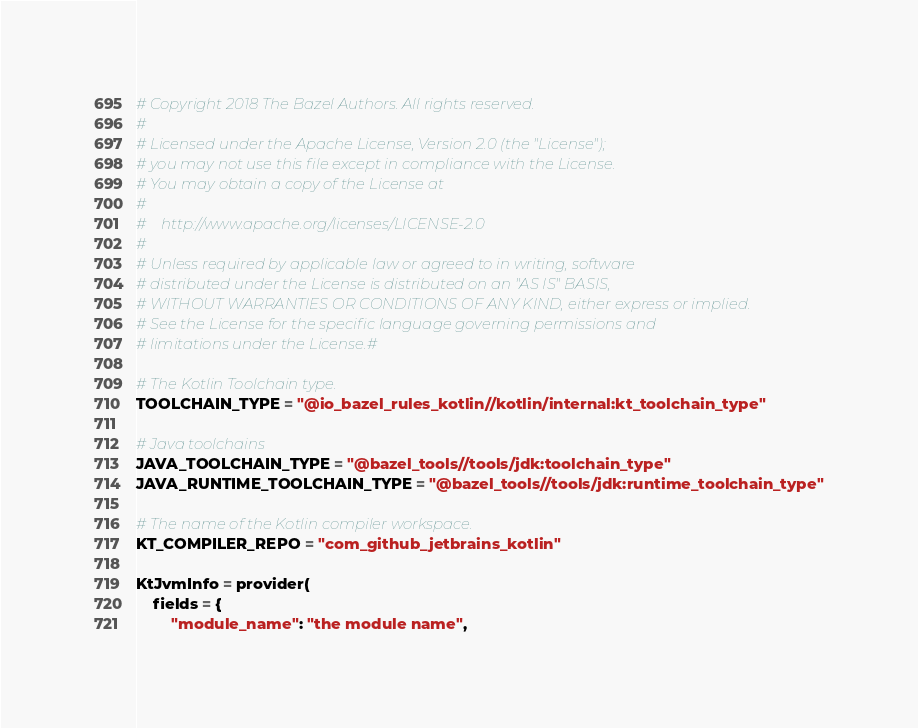<code> <loc_0><loc_0><loc_500><loc_500><_Python_># Copyright 2018 The Bazel Authors. All rights reserved.
#
# Licensed under the Apache License, Version 2.0 (the "License");
# you may not use this file except in compliance with the License.
# You may obtain a copy of the License at
#
#    http://www.apache.org/licenses/LICENSE-2.0
#
# Unless required by applicable law or agreed to in writing, software
# distributed under the License is distributed on an "AS IS" BASIS,
# WITHOUT WARRANTIES OR CONDITIONS OF ANY KIND, either express or implied.
# See the License for the specific language governing permissions and
# limitations under the License.#

# The Kotlin Toolchain type.
TOOLCHAIN_TYPE = "@io_bazel_rules_kotlin//kotlin/internal:kt_toolchain_type"

# Java toolchains
JAVA_TOOLCHAIN_TYPE = "@bazel_tools//tools/jdk:toolchain_type"
JAVA_RUNTIME_TOOLCHAIN_TYPE = "@bazel_tools//tools/jdk:runtime_toolchain_type"

# The name of the Kotlin compiler workspace.
KT_COMPILER_REPO = "com_github_jetbrains_kotlin"

KtJvmInfo = provider(
    fields = {
        "module_name": "the module name",</code> 